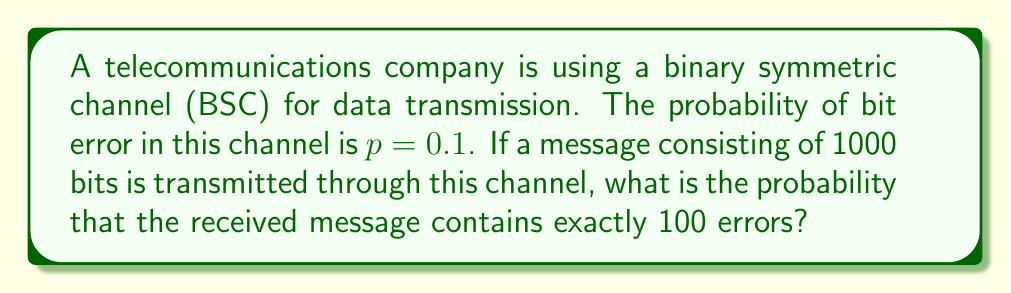Can you answer this question? To solve this problem, we need to use the binomial distribution, as we're dealing with a fixed number of independent trials (bits transmitted) where each trial has two possible outcomes (error or no error).

1) In a BSC, each bit has an independent probability $p$ of being flipped (error occurring).

2) We want to find the probability of exactly 100 errors in 1000 bits.

3) This scenario follows a binomial distribution with parameters:
   $n = 1000$ (number of bits)
   $k = 100$ (number of errors)
   $p = 0.1$ (probability of error for each bit)

4) The probability mass function for the binomial distribution is:

   $$P(X = k) = \binom{n}{k} p^k (1-p)^{n-k}$$

5) Substituting our values:

   $$P(X = 100) = \binom{1000}{100} (0.1)^{100} (0.9)^{900}$$

6) Calculate the binomial coefficient:
   
   $$\binom{1000}{100} = \frac{1000!}{100!(1000-100)!} = \frac{1000!}{100!900!}$$

7) Use a calculator or computer to evaluate this expression:

   $$P(X = 100) \approx 6.38 \times 10^{-3}$$

Therefore, the probability of receiving exactly 100 errors in the 1000-bit message is approximately 0.00638 or 0.638%.
Answer: $6.38 \times 10^{-3}$ or $0.00638$ or $0.638\%$ 